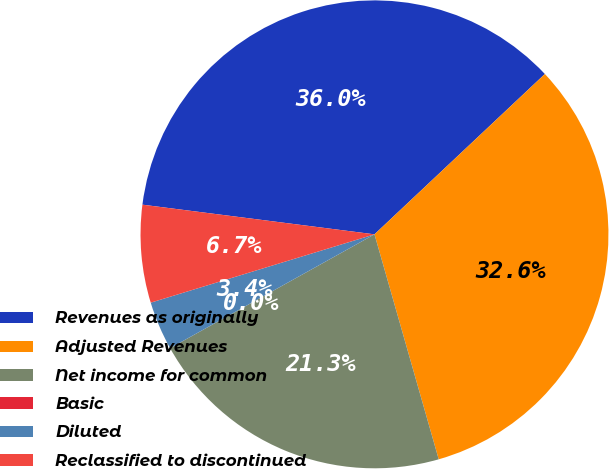Convert chart to OTSL. <chart><loc_0><loc_0><loc_500><loc_500><pie_chart><fcel>Revenues as originally<fcel>Adjusted Revenues<fcel>Net income for common<fcel>Basic<fcel>Diluted<fcel>Reclassified to discontinued<nl><fcel>35.96%<fcel>32.59%<fcel>21.34%<fcel>0.0%<fcel>3.37%<fcel>6.74%<nl></chart> 